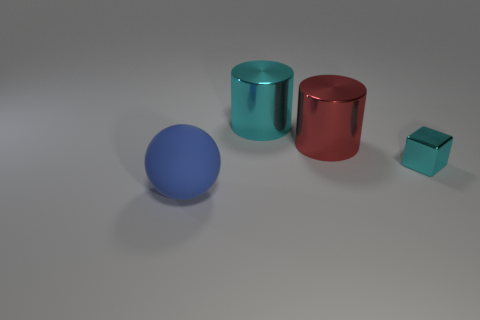What number of small cyan objects are in front of the tiny metal cube?
Your response must be concise. 0. Do the small metallic cube and the ball have the same color?
Offer a very short reply. No. There is another tiny object that is made of the same material as the red thing; what is its shape?
Your answer should be very brief. Cube. Is the shape of the cyan metallic object that is to the left of the large red metal cylinder the same as  the large blue object?
Provide a succinct answer. No. What number of blue objects are large balls or large objects?
Your answer should be very brief. 1. Are there an equal number of large red cylinders and big cylinders?
Give a very brief answer. No. Is the number of cyan cylinders that are in front of the large red cylinder the same as the number of big blue rubber spheres in front of the big blue thing?
Give a very brief answer. Yes. There is a big shiny cylinder that is in front of the cyan metal object to the left of the metal cylinder that is in front of the cyan metallic cylinder; what is its color?
Your response must be concise. Red. Is there anything else that has the same color as the sphere?
Your response must be concise. No. There is a big metal thing that is the same color as the shiny block; what is its shape?
Ensure brevity in your answer.  Cylinder. 